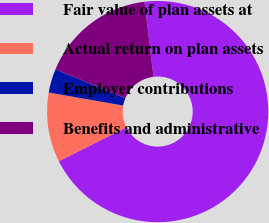Convert chart. <chart><loc_0><loc_0><loc_500><loc_500><pie_chart><fcel>Fair value of plan assets at<fcel>Actual return on plan assets<fcel>Employer contributions<fcel>Benefits and administrative<nl><fcel>69.49%<fcel>10.17%<fcel>3.48%<fcel>16.86%<nl></chart> 